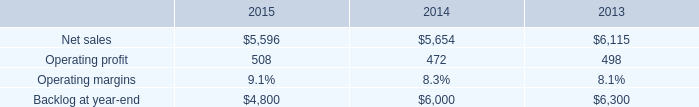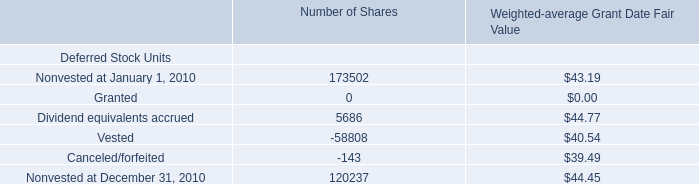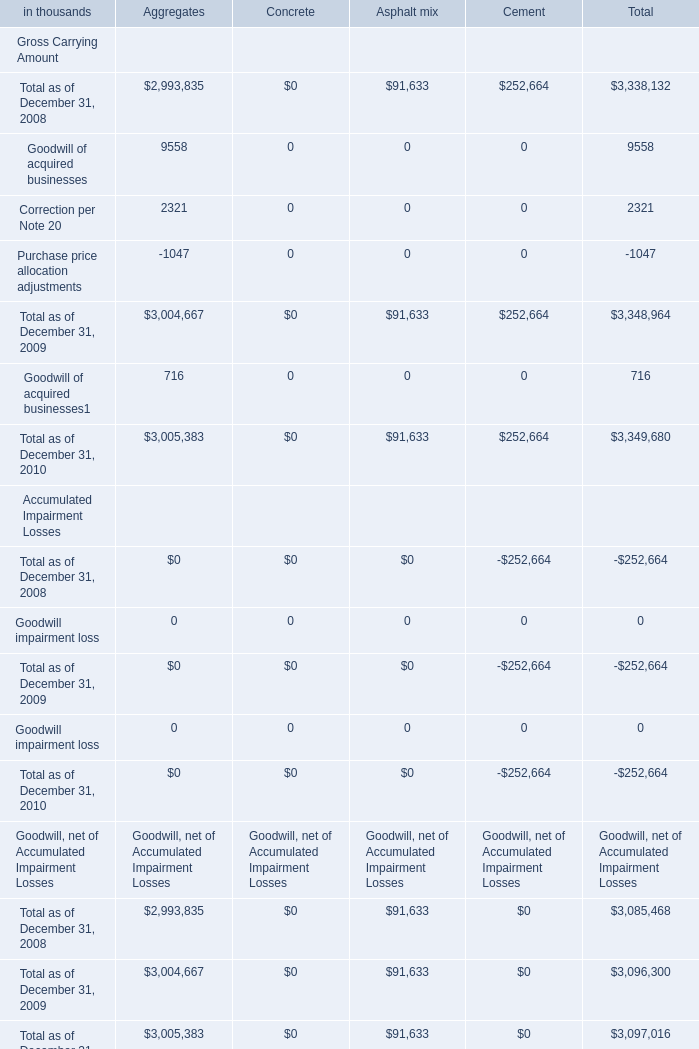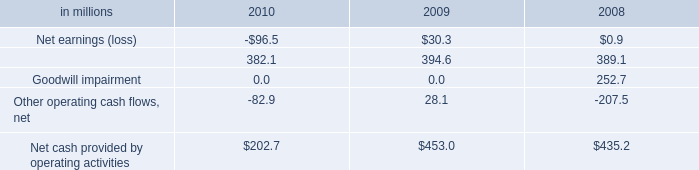what's the total amount of Nonvested at December 31, 2010 of Number of Shares, and Net sales of 2015 ? 
Computations: (120237.0 + 5596.0)
Answer: 125833.0. 